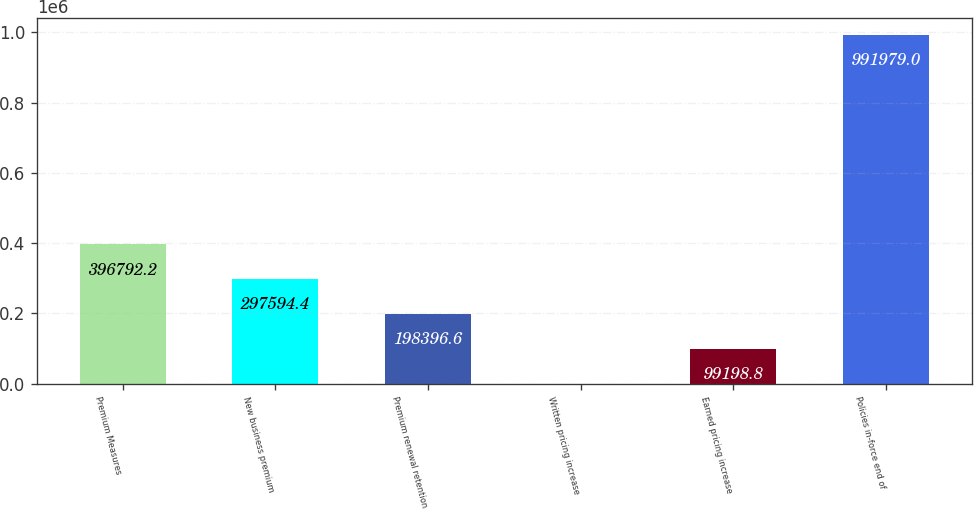Convert chart to OTSL. <chart><loc_0><loc_0><loc_500><loc_500><bar_chart><fcel>Premium Measures<fcel>New business premium<fcel>Premium renewal retention<fcel>Written pricing increase<fcel>Earned pricing increase<fcel>Policies in-force end of<nl><fcel>396792<fcel>297594<fcel>198397<fcel>1<fcel>99198.8<fcel>991979<nl></chart> 